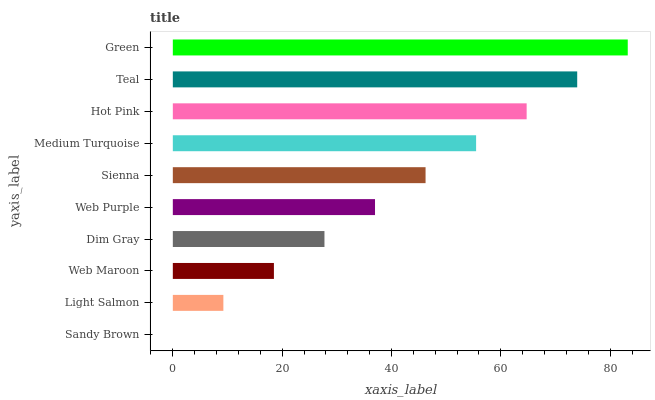Is Sandy Brown the minimum?
Answer yes or no. Yes. Is Green the maximum?
Answer yes or no. Yes. Is Light Salmon the minimum?
Answer yes or no. No. Is Light Salmon the maximum?
Answer yes or no. No. Is Light Salmon greater than Sandy Brown?
Answer yes or no. Yes. Is Sandy Brown less than Light Salmon?
Answer yes or no. Yes. Is Sandy Brown greater than Light Salmon?
Answer yes or no. No. Is Light Salmon less than Sandy Brown?
Answer yes or no. No. Is Sienna the high median?
Answer yes or no. Yes. Is Web Purple the low median?
Answer yes or no. Yes. Is Web Purple the high median?
Answer yes or no. No. Is Web Maroon the low median?
Answer yes or no. No. 